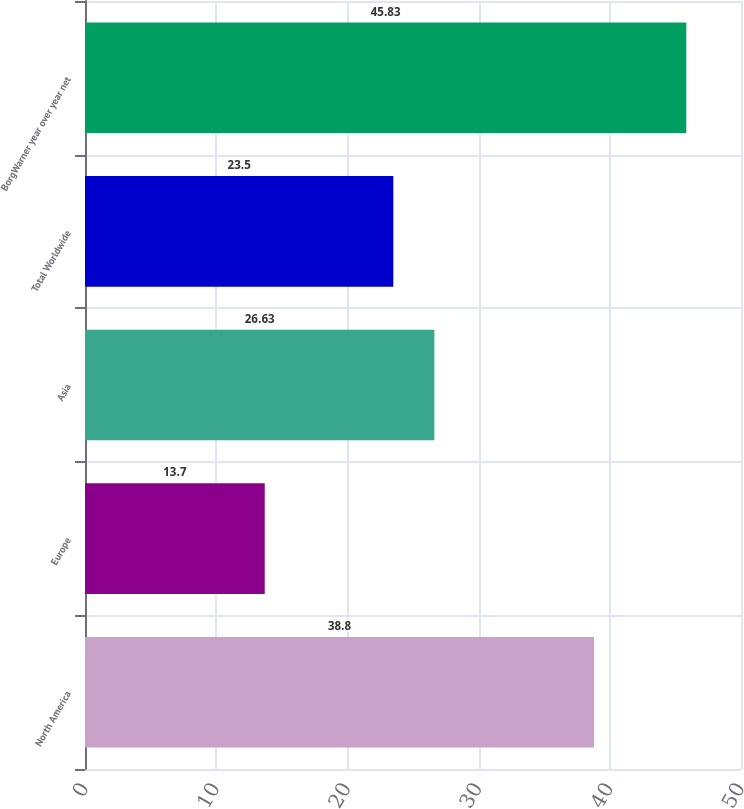Convert chart to OTSL. <chart><loc_0><loc_0><loc_500><loc_500><bar_chart><fcel>North America<fcel>Europe<fcel>Asia<fcel>Total Worldwide<fcel>BorgWarner year over year net<nl><fcel>38.8<fcel>13.7<fcel>26.63<fcel>23.5<fcel>45.83<nl></chart> 